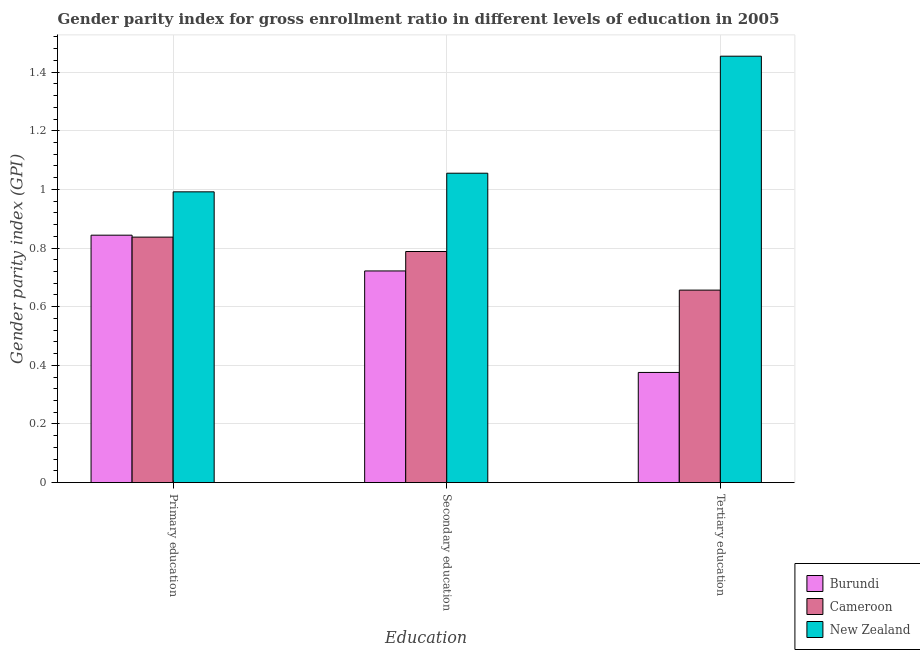Are the number of bars per tick equal to the number of legend labels?
Give a very brief answer. Yes. Are the number of bars on each tick of the X-axis equal?
Offer a terse response. Yes. How many bars are there on the 1st tick from the right?
Keep it short and to the point. 3. What is the label of the 1st group of bars from the left?
Offer a very short reply. Primary education. What is the gender parity index in secondary education in Burundi?
Provide a succinct answer. 0.72. Across all countries, what is the maximum gender parity index in tertiary education?
Ensure brevity in your answer.  1.45. Across all countries, what is the minimum gender parity index in tertiary education?
Your response must be concise. 0.38. In which country was the gender parity index in primary education maximum?
Make the answer very short. New Zealand. In which country was the gender parity index in secondary education minimum?
Provide a short and direct response. Burundi. What is the total gender parity index in tertiary education in the graph?
Offer a very short reply. 2.49. What is the difference between the gender parity index in secondary education in Burundi and that in Cameroon?
Offer a terse response. -0.07. What is the difference between the gender parity index in secondary education in New Zealand and the gender parity index in primary education in Cameroon?
Give a very brief answer. 0.22. What is the average gender parity index in secondary education per country?
Provide a short and direct response. 0.86. What is the difference between the gender parity index in tertiary education and gender parity index in secondary education in New Zealand?
Your response must be concise. 0.4. What is the ratio of the gender parity index in tertiary education in Cameroon to that in New Zealand?
Provide a succinct answer. 0.45. Is the gender parity index in secondary education in New Zealand less than that in Cameroon?
Give a very brief answer. No. Is the difference between the gender parity index in secondary education in Cameroon and Burundi greater than the difference between the gender parity index in tertiary education in Cameroon and Burundi?
Give a very brief answer. No. What is the difference between the highest and the second highest gender parity index in secondary education?
Your answer should be compact. 0.27. What is the difference between the highest and the lowest gender parity index in tertiary education?
Offer a terse response. 1.08. What does the 2nd bar from the left in Primary education represents?
Make the answer very short. Cameroon. What does the 2nd bar from the right in Tertiary education represents?
Your answer should be compact. Cameroon. Is it the case that in every country, the sum of the gender parity index in primary education and gender parity index in secondary education is greater than the gender parity index in tertiary education?
Offer a very short reply. Yes. How many bars are there?
Provide a succinct answer. 9. Are all the bars in the graph horizontal?
Your answer should be very brief. No. How many countries are there in the graph?
Ensure brevity in your answer.  3. Does the graph contain any zero values?
Offer a terse response. No. What is the title of the graph?
Keep it short and to the point. Gender parity index for gross enrollment ratio in different levels of education in 2005. Does "High income: nonOECD" appear as one of the legend labels in the graph?
Keep it short and to the point. No. What is the label or title of the X-axis?
Your response must be concise. Education. What is the label or title of the Y-axis?
Make the answer very short. Gender parity index (GPI). What is the Gender parity index (GPI) in Burundi in Primary education?
Your answer should be compact. 0.84. What is the Gender parity index (GPI) of Cameroon in Primary education?
Offer a very short reply. 0.84. What is the Gender parity index (GPI) of New Zealand in Primary education?
Keep it short and to the point. 0.99. What is the Gender parity index (GPI) of Burundi in Secondary education?
Provide a short and direct response. 0.72. What is the Gender parity index (GPI) of Cameroon in Secondary education?
Ensure brevity in your answer.  0.79. What is the Gender parity index (GPI) of New Zealand in Secondary education?
Offer a very short reply. 1.06. What is the Gender parity index (GPI) in Burundi in Tertiary education?
Offer a terse response. 0.38. What is the Gender parity index (GPI) in Cameroon in Tertiary education?
Your answer should be very brief. 0.66. What is the Gender parity index (GPI) in New Zealand in Tertiary education?
Offer a terse response. 1.45. Across all Education, what is the maximum Gender parity index (GPI) of Burundi?
Offer a terse response. 0.84. Across all Education, what is the maximum Gender parity index (GPI) in Cameroon?
Offer a terse response. 0.84. Across all Education, what is the maximum Gender parity index (GPI) of New Zealand?
Make the answer very short. 1.45. Across all Education, what is the minimum Gender parity index (GPI) of Burundi?
Your answer should be compact. 0.38. Across all Education, what is the minimum Gender parity index (GPI) of Cameroon?
Offer a very short reply. 0.66. Across all Education, what is the minimum Gender parity index (GPI) in New Zealand?
Provide a succinct answer. 0.99. What is the total Gender parity index (GPI) in Burundi in the graph?
Provide a short and direct response. 1.94. What is the total Gender parity index (GPI) in Cameroon in the graph?
Make the answer very short. 2.28. What is the total Gender parity index (GPI) of New Zealand in the graph?
Your answer should be very brief. 3.5. What is the difference between the Gender parity index (GPI) in Burundi in Primary education and that in Secondary education?
Provide a succinct answer. 0.12. What is the difference between the Gender parity index (GPI) of Cameroon in Primary education and that in Secondary education?
Provide a succinct answer. 0.05. What is the difference between the Gender parity index (GPI) of New Zealand in Primary education and that in Secondary education?
Keep it short and to the point. -0.06. What is the difference between the Gender parity index (GPI) in Burundi in Primary education and that in Tertiary education?
Give a very brief answer. 0.47. What is the difference between the Gender parity index (GPI) of Cameroon in Primary education and that in Tertiary education?
Your answer should be very brief. 0.18. What is the difference between the Gender parity index (GPI) in New Zealand in Primary education and that in Tertiary education?
Your answer should be compact. -0.46. What is the difference between the Gender parity index (GPI) of Burundi in Secondary education and that in Tertiary education?
Your response must be concise. 0.35. What is the difference between the Gender parity index (GPI) in Cameroon in Secondary education and that in Tertiary education?
Keep it short and to the point. 0.13. What is the difference between the Gender parity index (GPI) of New Zealand in Secondary education and that in Tertiary education?
Keep it short and to the point. -0.4. What is the difference between the Gender parity index (GPI) in Burundi in Primary education and the Gender parity index (GPI) in Cameroon in Secondary education?
Make the answer very short. 0.06. What is the difference between the Gender parity index (GPI) in Burundi in Primary education and the Gender parity index (GPI) in New Zealand in Secondary education?
Your response must be concise. -0.21. What is the difference between the Gender parity index (GPI) in Cameroon in Primary education and the Gender parity index (GPI) in New Zealand in Secondary education?
Offer a terse response. -0.22. What is the difference between the Gender parity index (GPI) in Burundi in Primary education and the Gender parity index (GPI) in Cameroon in Tertiary education?
Provide a short and direct response. 0.19. What is the difference between the Gender parity index (GPI) in Burundi in Primary education and the Gender parity index (GPI) in New Zealand in Tertiary education?
Offer a terse response. -0.61. What is the difference between the Gender parity index (GPI) in Cameroon in Primary education and the Gender parity index (GPI) in New Zealand in Tertiary education?
Your answer should be compact. -0.62. What is the difference between the Gender parity index (GPI) in Burundi in Secondary education and the Gender parity index (GPI) in Cameroon in Tertiary education?
Offer a very short reply. 0.07. What is the difference between the Gender parity index (GPI) in Burundi in Secondary education and the Gender parity index (GPI) in New Zealand in Tertiary education?
Offer a very short reply. -0.73. What is the difference between the Gender parity index (GPI) in Cameroon in Secondary education and the Gender parity index (GPI) in New Zealand in Tertiary education?
Provide a succinct answer. -0.67. What is the average Gender parity index (GPI) in Burundi per Education?
Give a very brief answer. 0.65. What is the average Gender parity index (GPI) in Cameroon per Education?
Give a very brief answer. 0.76. What is the average Gender parity index (GPI) in New Zealand per Education?
Give a very brief answer. 1.17. What is the difference between the Gender parity index (GPI) in Burundi and Gender parity index (GPI) in Cameroon in Primary education?
Make the answer very short. 0.01. What is the difference between the Gender parity index (GPI) in Burundi and Gender parity index (GPI) in New Zealand in Primary education?
Offer a very short reply. -0.15. What is the difference between the Gender parity index (GPI) of Cameroon and Gender parity index (GPI) of New Zealand in Primary education?
Give a very brief answer. -0.15. What is the difference between the Gender parity index (GPI) of Burundi and Gender parity index (GPI) of Cameroon in Secondary education?
Provide a short and direct response. -0.07. What is the difference between the Gender parity index (GPI) in Burundi and Gender parity index (GPI) in New Zealand in Secondary education?
Ensure brevity in your answer.  -0.33. What is the difference between the Gender parity index (GPI) in Cameroon and Gender parity index (GPI) in New Zealand in Secondary education?
Provide a succinct answer. -0.27. What is the difference between the Gender parity index (GPI) in Burundi and Gender parity index (GPI) in Cameroon in Tertiary education?
Make the answer very short. -0.28. What is the difference between the Gender parity index (GPI) of Burundi and Gender parity index (GPI) of New Zealand in Tertiary education?
Ensure brevity in your answer.  -1.08. What is the difference between the Gender parity index (GPI) in Cameroon and Gender parity index (GPI) in New Zealand in Tertiary education?
Ensure brevity in your answer.  -0.8. What is the ratio of the Gender parity index (GPI) of Burundi in Primary education to that in Secondary education?
Ensure brevity in your answer.  1.17. What is the ratio of the Gender parity index (GPI) in Cameroon in Primary education to that in Secondary education?
Keep it short and to the point. 1.06. What is the ratio of the Gender parity index (GPI) in New Zealand in Primary education to that in Secondary education?
Your answer should be compact. 0.94. What is the ratio of the Gender parity index (GPI) in Burundi in Primary education to that in Tertiary education?
Provide a succinct answer. 2.25. What is the ratio of the Gender parity index (GPI) in Cameroon in Primary education to that in Tertiary education?
Ensure brevity in your answer.  1.28. What is the ratio of the Gender parity index (GPI) of New Zealand in Primary education to that in Tertiary education?
Keep it short and to the point. 0.68. What is the ratio of the Gender parity index (GPI) of Burundi in Secondary education to that in Tertiary education?
Provide a succinct answer. 1.92. What is the ratio of the Gender parity index (GPI) in Cameroon in Secondary education to that in Tertiary education?
Make the answer very short. 1.2. What is the ratio of the Gender parity index (GPI) of New Zealand in Secondary education to that in Tertiary education?
Your answer should be compact. 0.73. What is the difference between the highest and the second highest Gender parity index (GPI) of Burundi?
Offer a terse response. 0.12. What is the difference between the highest and the second highest Gender parity index (GPI) of Cameroon?
Give a very brief answer. 0.05. What is the difference between the highest and the second highest Gender parity index (GPI) of New Zealand?
Make the answer very short. 0.4. What is the difference between the highest and the lowest Gender parity index (GPI) in Burundi?
Make the answer very short. 0.47. What is the difference between the highest and the lowest Gender parity index (GPI) of Cameroon?
Your response must be concise. 0.18. What is the difference between the highest and the lowest Gender parity index (GPI) of New Zealand?
Offer a very short reply. 0.46. 